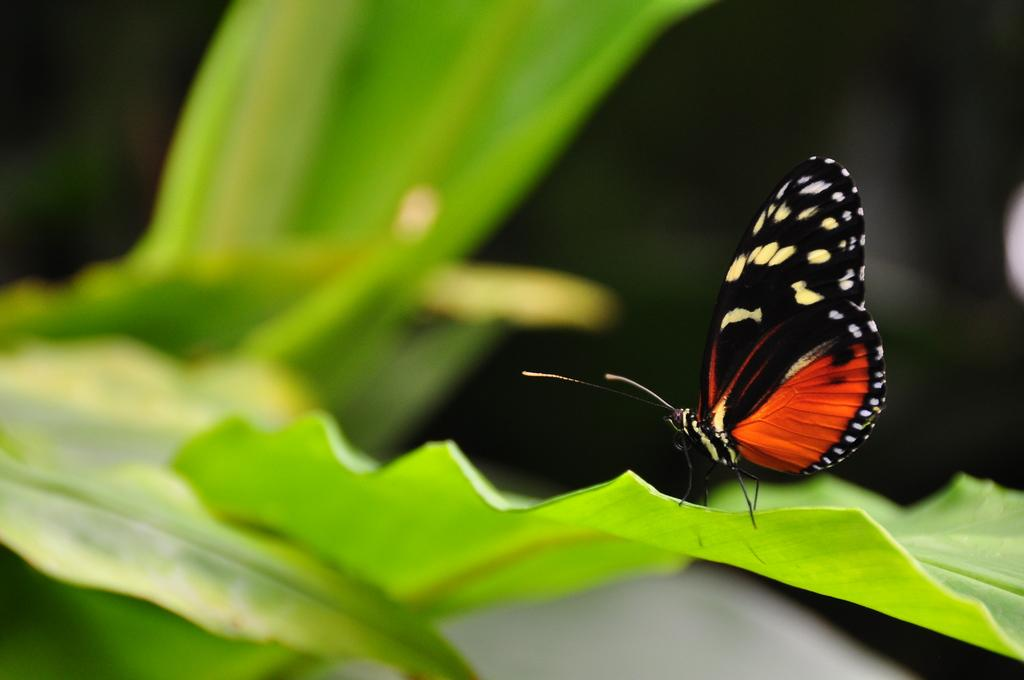What is the main subject in the image? There is a butterfly in the image. Where is the butterfly located? The butterfly is on a leaf. Who is the expert operating the machine in the image? There is no expert or machine present in the image; it features a butterfly on a leaf. 